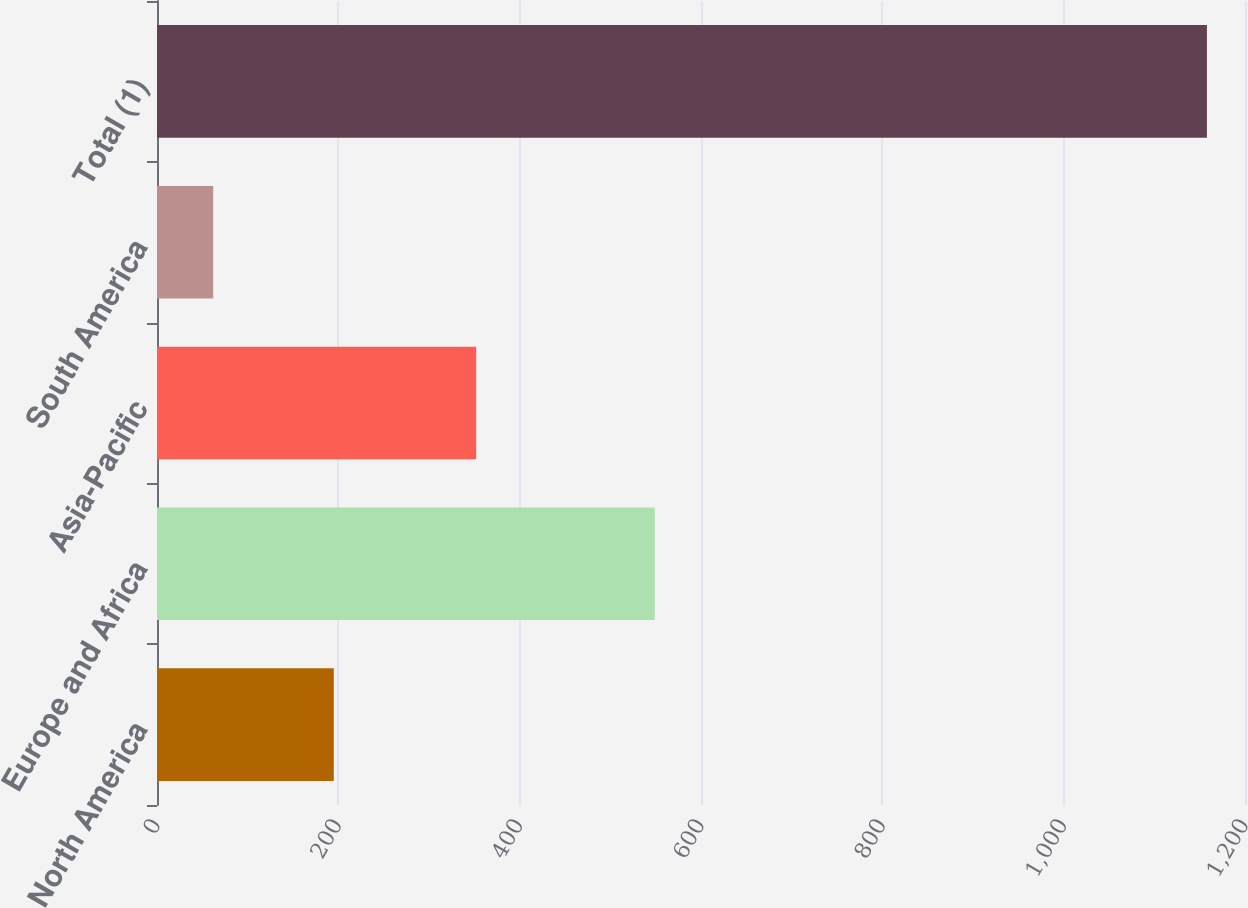Convert chart. <chart><loc_0><loc_0><loc_500><loc_500><bar_chart><fcel>North America<fcel>Europe and Africa<fcel>Asia-Pacific<fcel>South America<fcel>Total (1)<nl><fcel>195<fcel>549<fcel>352<fcel>62<fcel>1158<nl></chart> 